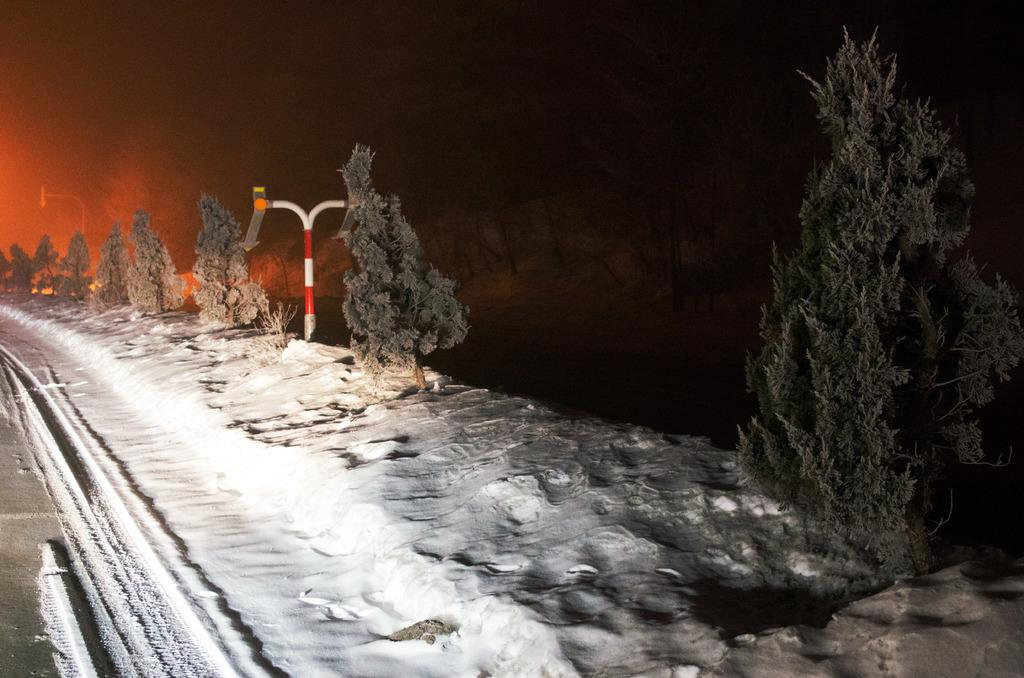What type of weather condition is depicted in the image? There is snow in the image, which suggests a cold or wintry weather condition. What type of natural vegetation is visible in the image? There are trees in the image. What might be used for sliding or gliding in the image? There is a board in the image, which could be used for sliding or gliding. What type of structures are present in the image? There are poles in the image. What is the color of the background in the image? The background of the image is dark. What type of wall can be seen in the image? There is no wall present in the image. Who is the creator of the snow in the image? The image is a photograph, not a creation, so there is no specific creator of the snow in the image. 